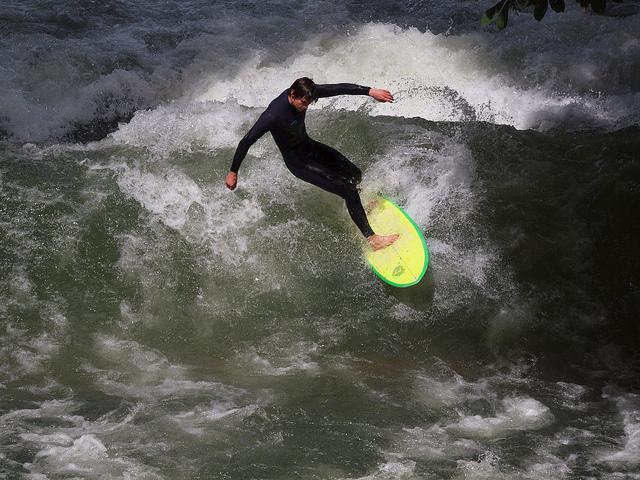How many boards in the water?
Give a very brief answer. 1. How many skateboards are in the image?
Give a very brief answer. 0. 